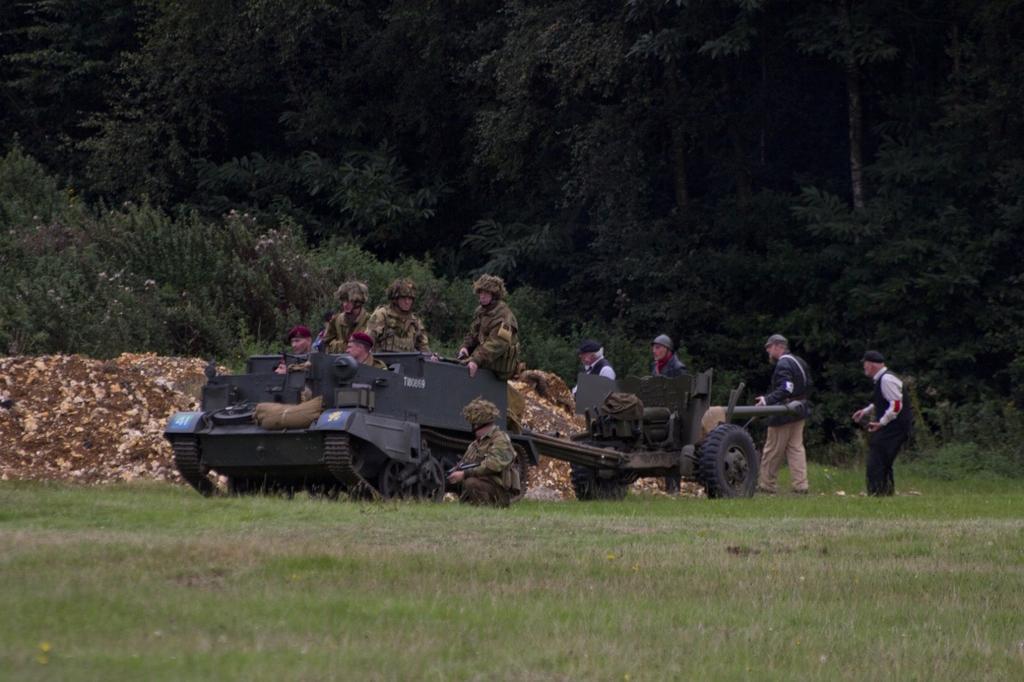Could you give a brief overview of what you see in this image? In the foreground of the picture there is grass. In the center of the picture there is a army tank and many soldiers. In the center of the picture there is soil and there are few people walking behind it. In the background there are trees. 